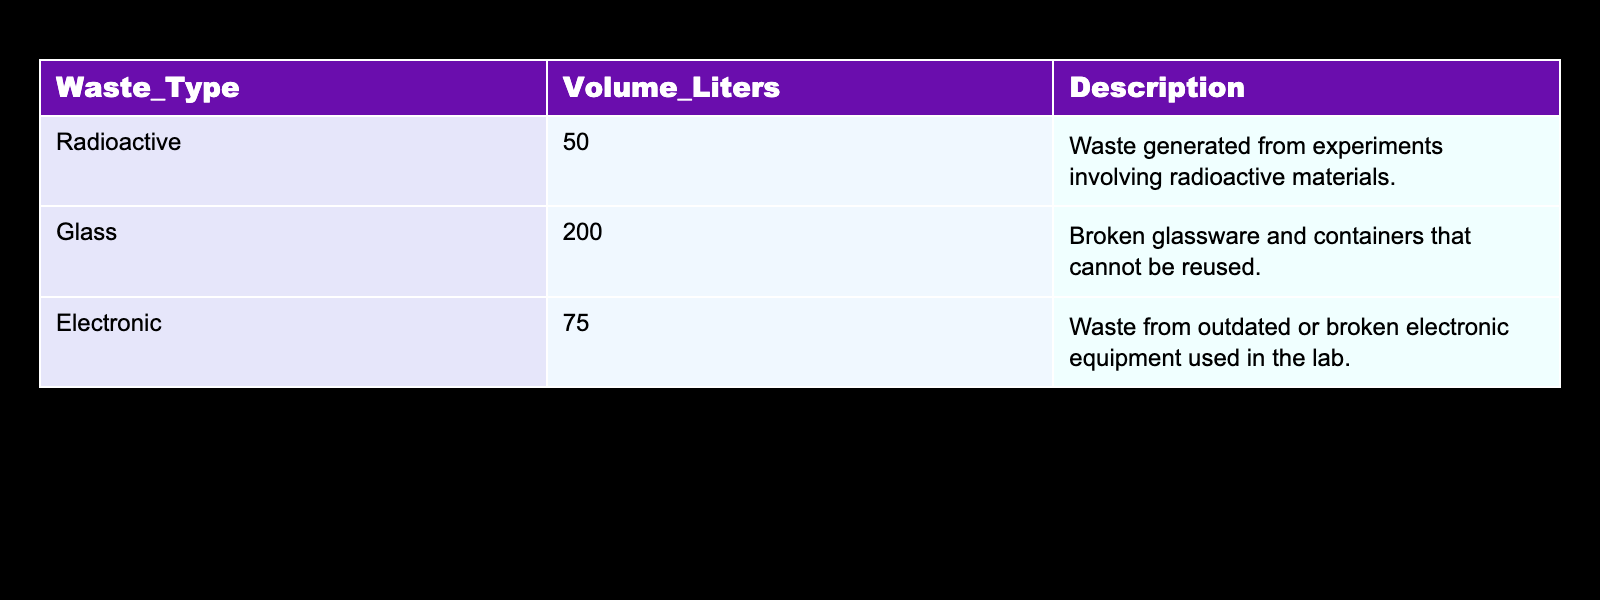What is the total volume of laboratory waste generated? To find the total volume, we sum the volume of all waste types: 50 liters (Radioactive) + 200 liters (Glass) + 75 liters (Electronic) = 325 liters.
Answer: 325 liters Which type of waste has the highest volume? By comparing the volumes in the table: Radioactive (50 liters), Glass (200 liters), and Electronic (75 liters), it is clear that Glass waste at 200 liters has the highest volume.
Answer: Glass Is the volume of Electronic waste greater than 100 liters? The volume of Electronic waste is 75 liters, which is less than 100 liters. Therefore, the statement is false.
Answer: No What is the combined volume of Radioactive and Electronic waste? To combine the volumes of Radioactive and Electronic waste, we add 50 liters (Radioactive) + 75 liters (Electronic) = 125 liters.
Answer: 125 liters Does the table indicate any waste type that exceeds 100 liters in volume? Looking at the table, the only type with a volume greater than 100 liters is Glass at 200 liters. Therefore, the answer is yes.
Answer: Yes What percentage of the total waste volume does the Radioactive waste represent? First, calculate the total waste volume of 325 liters. Then, find the percentage: (50 liters for Radioactive / 325 liters total) * 100 = approximately 15.38%.
Answer: 15.38% If we categorize the waste types beyond those listed in the table, what would be the average volume of the waste types present? There are three waste types (Radioactive, Glass, and Electronic), and their volumes add to 325 liters. To find the average: 325 liters / 3 = approximately 108.33 liters per type.
Answer: 108.33 liters Is the description for Glass waste different from that of Electronic waste? The description for Glass refers to broken glassware and containers, while Electronic waste is about outdated or broken electronic equipment. Hence, they are different.
Answer: Yes 